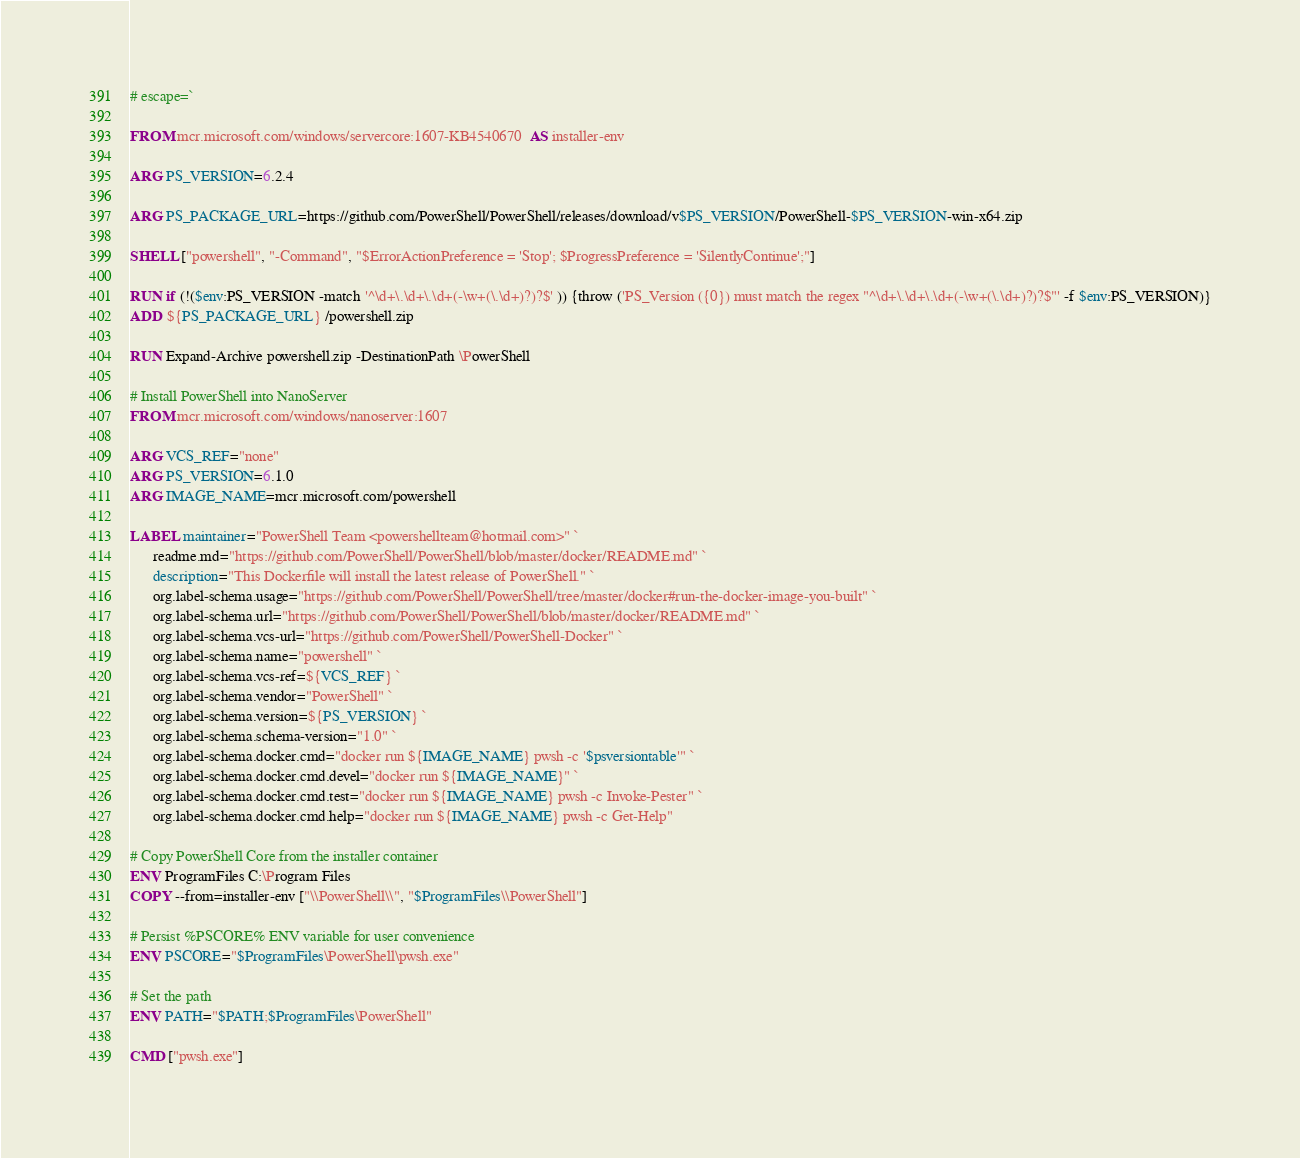<code> <loc_0><loc_0><loc_500><loc_500><_Dockerfile_># escape=`

FROM mcr.microsoft.com/windows/servercore:1607-KB4540670  AS installer-env

ARG PS_VERSION=6.2.4

ARG PS_PACKAGE_URL=https://github.com/PowerShell/PowerShell/releases/download/v$PS_VERSION/PowerShell-$PS_VERSION-win-x64.zip

SHELL ["powershell", "-Command", "$ErrorActionPreference = 'Stop'; $ProgressPreference = 'SilentlyContinue';"]

RUN if (!($env:PS_VERSION -match '^\d+\.\d+\.\d+(-\w+(\.\d+)?)?$' )) {throw ('PS_Version ({0}) must match the regex "^\d+\.\d+\.\d+(-\w+(\.\d+)?)?$"' -f $env:PS_VERSION)}
ADD ${PS_PACKAGE_URL} /powershell.zip

RUN Expand-Archive powershell.zip -DestinationPath \PowerShell

# Install PowerShell into NanoServer
FROM mcr.microsoft.com/windows/nanoserver:1607

ARG VCS_REF="none"
ARG PS_VERSION=6.1.0
ARG IMAGE_NAME=mcr.microsoft.com/powershell

LABEL maintainer="PowerShell Team <powershellteam@hotmail.com>" `
      readme.md="https://github.com/PowerShell/PowerShell/blob/master/docker/README.md" `
      description="This Dockerfile will install the latest release of PowerShell." `
      org.label-schema.usage="https://github.com/PowerShell/PowerShell/tree/master/docker#run-the-docker-image-you-built" `
      org.label-schema.url="https://github.com/PowerShell/PowerShell/blob/master/docker/README.md" `
      org.label-schema.vcs-url="https://github.com/PowerShell/PowerShell-Docker" `
      org.label-schema.name="powershell" `
      org.label-schema.vcs-ref=${VCS_REF} `
      org.label-schema.vendor="PowerShell" `
      org.label-schema.version=${PS_VERSION} `
      org.label-schema.schema-version="1.0" `
      org.label-schema.docker.cmd="docker run ${IMAGE_NAME} pwsh -c '$psversiontable'" `
      org.label-schema.docker.cmd.devel="docker run ${IMAGE_NAME}" `
      org.label-schema.docker.cmd.test="docker run ${IMAGE_NAME} pwsh -c Invoke-Pester" `
      org.label-schema.docker.cmd.help="docker run ${IMAGE_NAME} pwsh -c Get-Help"

# Copy PowerShell Core from the installer container
ENV ProgramFiles C:\Program Files
COPY --from=installer-env ["\\PowerShell\\", "$ProgramFiles\\PowerShell"]

# Persist %PSCORE% ENV variable for user convenience
ENV PSCORE="$ProgramFiles\PowerShell\pwsh.exe"

# Set the path
ENV PATH="$PATH;$ProgramFiles\PowerShell"

CMD ["pwsh.exe"]
</code> 